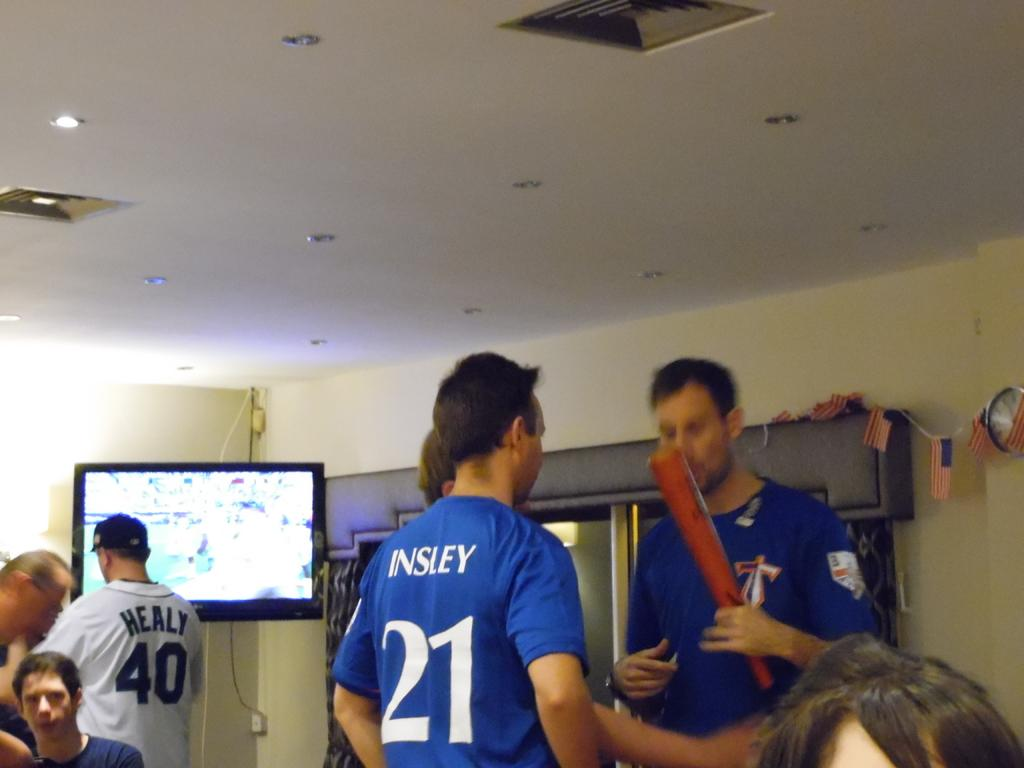<image>
Share a concise interpretation of the image provided. a person has the number 21 on the back of their shirt 